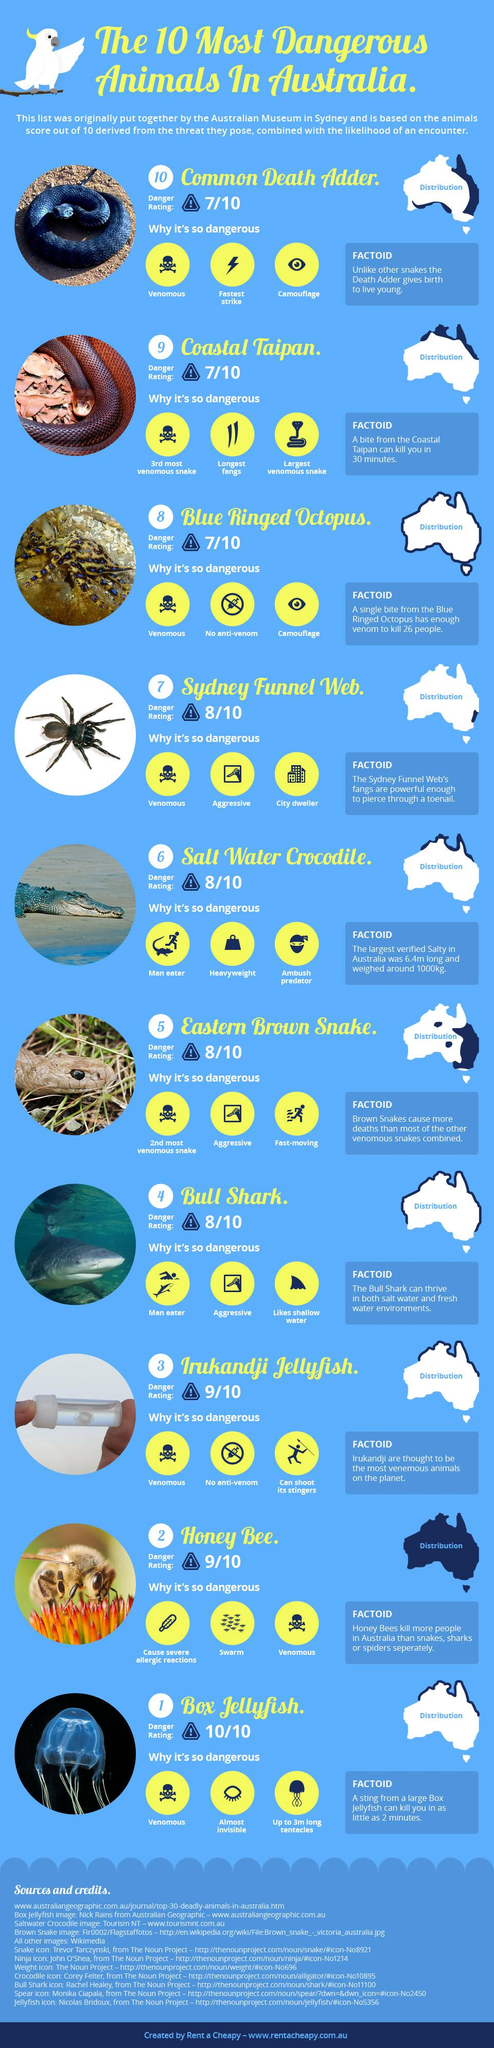Outline some significant characteristics in this image. The Coastal Taipan is the largest venomous snake found in Australia. The Eastern Brown Snake is the second most venomous snake found in Australia, with a toxic potency that can cause severe harm to humans and other animals. The Saltwater Crocodile is a man-eating reptile found in Australia that is known for its dangerous and deadly nature. 